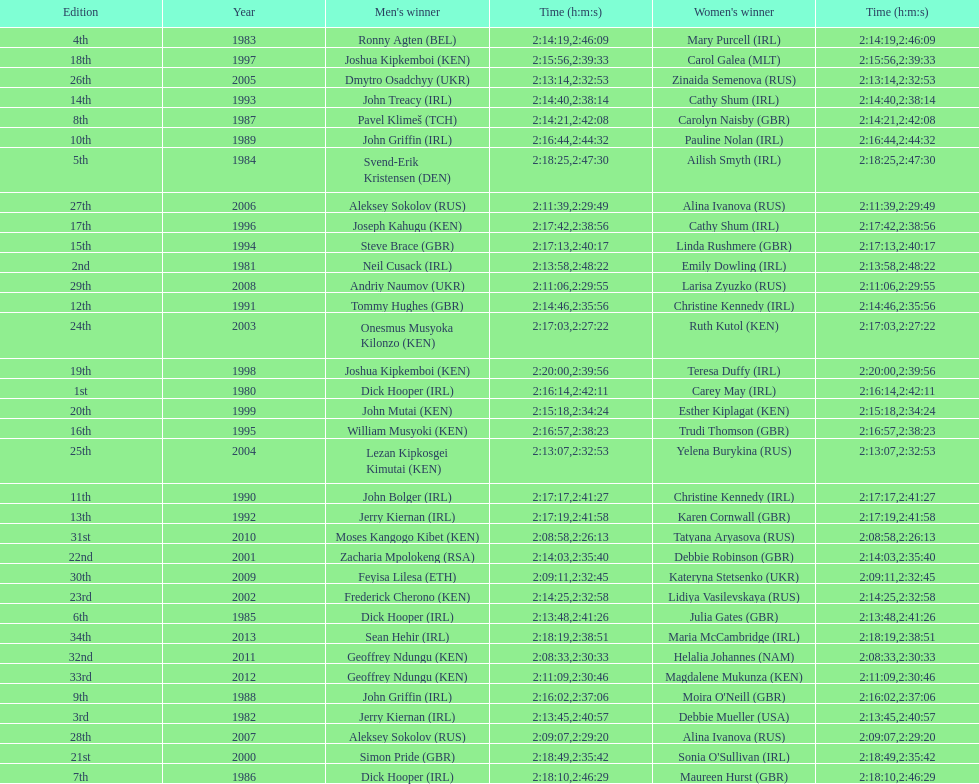How many women's winners are from kenya? 3. Parse the full table. {'header': ['Edition', 'Year', "Men's winner", 'Time (h:m:s)', "Women's winner", 'Time (h:m:s)'], 'rows': [['4th', '1983', 'Ronny Agten\xa0(BEL)', '2:14:19', 'Mary Purcell\xa0(IRL)', '2:46:09'], ['18th', '1997', 'Joshua Kipkemboi\xa0(KEN)', '2:15:56', 'Carol Galea\xa0(MLT)', '2:39:33'], ['26th', '2005', 'Dmytro Osadchyy\xa0(UKR)', '2:13:14', 'Zinaida Semenova\xa0(RUS)', '2:32:53'], ['14th', '1993', 'John Treacy\xa0(IRL)', '2:14:40', 'Cathy Shum\xa0(IRL)', '2:38:14'], ['8th', '1987', 'Pavel Klimeš\xa0(TCH)', '2:14:21', 'Carolyn Naisby\xa0(GBR)', '2:42:08'], ['10th', '1989', 'John Griffin\xa0(IRL)', '2:16:44', 'Pauline Nolan\xa0(IRL)', '2:44:32'], ['5th', '1984', 'Svend-Erik Kristensen\xa0(DEN)', '2:18:25', 'Ailish Smyth\xa0(IRL)', '2:47:30'], ['27th', '2006', 'Aleksey Sokolov\xa0(RUS)', '2:11:39', 'Alina Ivanova\xa0(RUS)', '2:29:49'], ['17th', '1996', 'Joseph Kahugu\xa0(KEN)', '2:17:42', 'Cathy Shum\xa0(IRL)', '2:38:56'], ['15th', '1994', 'Steve Brace\xa0(GBR)', '2:17:13', 'Linda Rushmere\xa0(GBR)', '2:40:17'], ['2nd', '1981', 'Neil Cusack\xa0(IRL)', '2:13:58', 'Emily Dowling\xa0(IRL)', '2:48:22'], ['29th', '2008', 'Andriy Naumov\xa0(UKR)', '2:11:06', 'Larisa Zyuzko\xa0(RUS)', '2:29:55'], ['12th', '1991', 'Tommy Hughes\xa0(GBR)', '2:14:46', 'Christine Kennedy\xa0(IRL)', '2:35:56'], ['24th', '2003', 'Onesmus Musyoka Kilonzo\xa0(KEN)', '2:17:03', 'Ruth Kutol\xa0(KEN)', '2:27:22'], ['19th', '1998', 'Joshua Kipkemboi\xa0(KEN)', '2:20:00', 'Teresa Duffy\xa0(IRL)', '2:39:56'], ['1st', '1980', 'Dick Hooper\xa0(IRL)', '2:16:14', 'Carey May\xa0(IRL)', '2:42:11'], ['20th', '1999', 'John Mutai\xa0(KEN)', '2:15:18', 'Esther Kiplagat\xa0(KEN)', '2:34:24'], ['16th', '1995', 'William Musyoki\xa0(KEN)', '2:16:57', 'Trudi Thomson\xa0(GBR)', '2:38:23'], ['25th', '2004', 'Lezan Kipkosgei Kimutai\xa0(KEN)', '2:13:07', 'Yelena Burykina\xa0(RUS)', '2:32:53'], ['11th', '1990', 'John Bolger\xa0(IRL)', '2:17:17', 'Christine Kennedy\xa0(IRL)', '2:41:27'], ['13th', '1992', 'Jerry Kiernan\xa0(IRL)', '2:17:19', 'Karen Cornwall\xa0(GBR)', '2:41:58'], ['31st', '2010', 'Moses Kangogo Kibet\xa0(KEN)', '2:08:58', 'Tatyana Aryasova\xa0(RUS)', '2:26:13'], ['22nd', '2001', 'Zacharia Mpolokeng\xa0(RSA)', '2:14:03', 'Debbie Robinson\xa0(GBR)', '2:35:40'], ['30th', '2009', 'Feyisa Lilesa\xa0(ETH)', '2:09:11', 'Kateryna Stetsenko\xa0(UKR)', '2:32:45'], ['23rd', '2002', 'Frederick Cherono\xa0(KEN)', '2:14:25', 'Lidiya Vasilevskaya\xa0(RUS)', '2:32:58'], ['6th', '1985', 'Dick Hooper\xa0(IRL)', '2:13:48', 'Julia Gates\xa0(GBR)', '2:41:26'], ['34th', '2013', 'Sean Hehir\xa0(IRL)', '2:18:19', 'Maria McCambridge\xa0(IRL)', '2:38:51'], ['32nd', '2011', 'Geoffrey Ndungu\xa0(KEN)', '2:08:33', 'Helalia Johannes\xa0(NAM)', '2:30:33'], ['33rd', '2012', 'Geoffrey Ndungu\xa0(KEN)', '2:11:09', 'Magdalene Mukunza\xa0(KEN)', '2:30:46'], ['9th', '1988', 'John Griffin\xa0(IRL)', '2:16:02', "Moira O'Neill\xa0(GBR)", '2:37:06'], ['3rd', '1982', 'Jerry Kiernan\xa0(IRL)', '2:13:45', 'Debbie Mueller\xa0(USA)', '2:40:57'], ['28th', '2007', 'Aleksey Sokolov\xa0(RUS)', '2:09:07', 'Alina Ivanova\xa0(RUS)', '2:29:20'], ['21st', '2000', 'Simon Pride\xa0(GBR)', '2:18:49', "Sonia O'Sullivan\xa0(IRL)", '2:35:42'], ['7th', '1986', 'Dick Hooper\xa0(IRL)', '2:18:10', 'Maureen Hurst\xa0(GBR)', '2:46:29']]} 